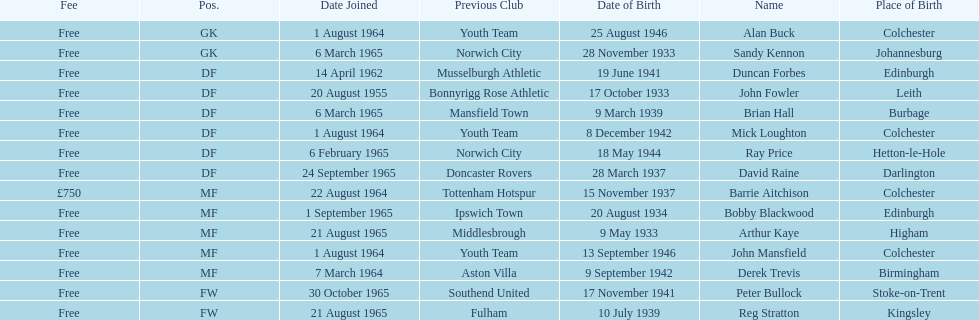Which player is the oldest? Arthur Kaye. 